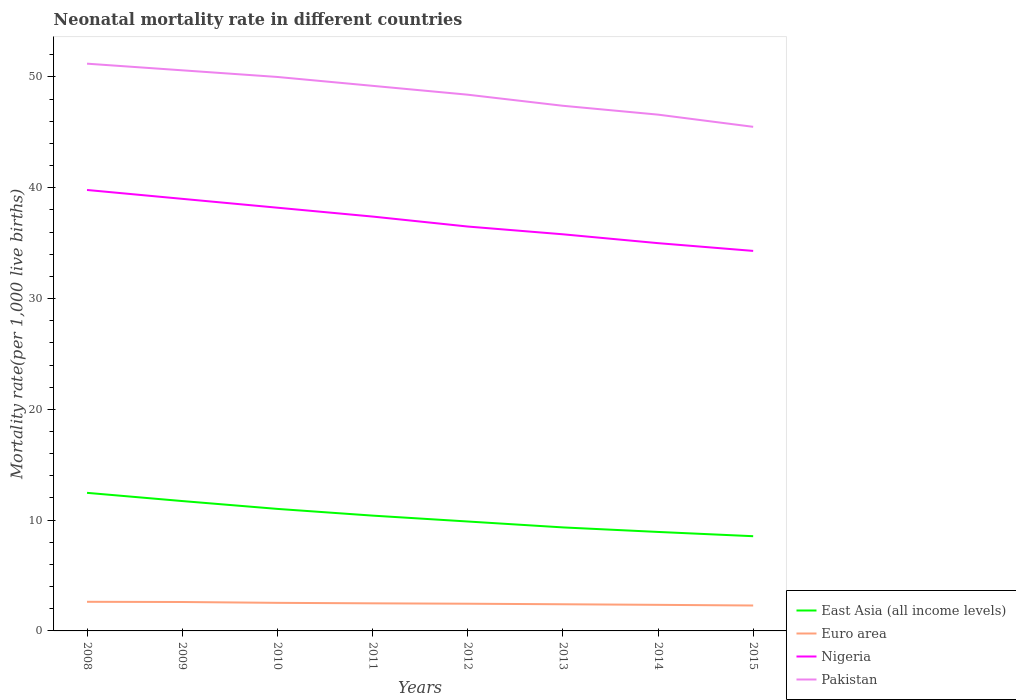How many different coloured lines are there?
Offer a very short reply. 4. Across all years, what is the maximum neonatal mortality rate in Euro area?
Your answer should be compact. 2.29. In which year was the neonatal mortality rate in Pakistan maximum?
Make the answer very short. 2015. What is the total neonatal mortality rate in Pakistan in the graph?
Give a very brief answer. 0.8. What is the difference between the highest and the second highest neonatal mortality rate in Pakistan?
Offer a very short reply. 5.7. How many lines are there?
Your answer should be compact. 4. How many years are there in the graph?
Offer a very short reply. 8. What is the difference between two consecutive major ticks on the Y-axis?
Provide a succinct answer. 10. Does the graph contain any zero values?
Provide a short and direct response. No. Where does the legend appear in the graph?
Make the answer very short. Bottom right. What is the title of the graph?
Offer a terse response. Neonatal mortality rate in different countries. Does "Turks and Caicos Islands" appear as one of the legend labels in the graph?
Your answer should be compact. No. What is the label or title of the Y-axis?
Your response must be concise. Mortality rate(per 1,0 live births). What is the Mortality rate(per 1,000 live births) of East Asia (all income levels) in 2008?
Give a very brief answer. 12.46. What is the Mortality rate(per 1,000 live births) in Euro area in 2008?
Offer a very short reply. 2.63. What is the Mortality rate(per 1,000 live births) of Nigeria in 2008?
Give a very brief answer. 39.8. What is the Mortality rate(per 1,000 live births) of Pakistan in 2008?
Ensure brevity in your answer.  51.2. What is the Mortality rate(per 1,000 live births) of East Asia (all income levels) in 2009?
Give a very brief answer. 11.72. What is the Mortality rate(per 1,000 live births) of Euro area in 2009?
Give a very brief answer. 2.61. What is the Mortality rate(per 1,000 live births) in Pakistan in 2009?
Give a very brief answer. 50.6. What is the Mortality rate(per 1,000 live births) in East Asia (all income levels) in 2010?
Your answer should be compact. 11.01. What is the Mortality rate(per 1,000 live births) of Euro area in 2010?
Offer a terse response. 2.53. What is the Mortality rate(per 1,000 live births) of Nigeria in 2010?
Ensure brevity in your answer.  38.2. What is the Mortality rate(per 1,000 live births) of East Asia (all income levels) in 2011?
Your response must be concise. 10.41. What is the Mortality rate(per 1,000 live births) of Euro area in 2011?
Offer a very short reply. 2.49. What is the Mortality rate(per 1,000 live births) in Nigeria in 2011?
Give a very brief answer. 37.4. What is the Mortality rate(per 1,000 live births) of Pakistan in 2011?
Your answer should be compact. 49.2. What is the Mortality rate(per 1,000 live births) of East Asia (all income levels) in 2012?
Your answer should be compact. 9.88. What is the Mortality rate(per 1,000 live births) of Euro area in 2012?
Your answer should be very brief. 2.46. What is the Mortality rate(per 1,000 live births) in Nigeria in 2012?
Give a very brief answer. 36.5. What is the Mortality rate(per 1,000 live births) in Pakistan in 2012?
Your answer should be compact. 48.4. What is the Mortality rate(per 1,000 live births) of East Asia (all income levels) in 2013?
Your answer should be very brief. 9.34. What is the Mortality rate(per 1,000 live births) in Euro area in 2013?
Keep it short and to the point. 2.41. What is the Mortality rate(per 1,000 live births) in Nigeria in 2013?
Offer a very short reply. 35.8. What is the Mortality rate(per 1,000 live births) of Pakistan in 2013?
Provide a short and direct response. 47.4. What is the Mortality rate(per 1,000 live births) of East Asia (all income levels) in 2014?
Keep it short and to the point. 8.93. What is the Mortality rate(per 1,000 live births) in Euro area in 2014?
Provide a short and direct response. 2.35. What is the Mortality rate(per 1,000 live births) in Pakistan in 2014?
Provide a short and direct response. 46.6. What is the Mortality rate(per 1,000 live births) of East Asia (all income levels) in 2015?
Keep it short and to the point. 8.55. What is the Mortality rate(per 1,000 live births) in Euro area in 2015?
Offer a very short reply. 2.29. What is the Mortality rate(per 1,000 live births) of Nigeria in 2015?
Your answer should be very brief. 34.3. What is the Mortality rate(per 1,000 live births) of Pakistan in 2015?
Your answer should be compact. 45.5. Across all years, what is the maximum Mortality rate(per 1,000 live births) of East Asia (all income levels)?
Offer a very short reply. 12.46. Across all years, what is the maximum Mortality rate(per 1,000 live births) of Euro area?
Your response must be concise. 2.63. Across all years, what is the maximum Mortality rate(per 1,000 live births) in Nigeria?
Your response must be concise. 39.8. Across all years, what is the maximum Mortality rate(per 1,000 live births) in Pakistan?
Your answer should be compact. 51.2. Across all years, what is the minimum Mortality rate(per 1,000 live births) in East Asia (all income levels)?
Give a very brief answer. 8.55. Across all years, what is the minimum Mortality rate(per 1,000 live births) in Euro area?
Give a very brief answer. 2.29. Across all years, what is the minimum Mortality rate(per 1,000 live births) in Nigeria?
Provide a short and direct response. 34.3. Across all years, what is the minimum Mortality rate(per 1,000 live births) of Pakistan?
Make the answer very short. 45.5. What is the total Mortality rate(per 1,000 live births) of East Asia (all income levels) in the graph?
Your answer should be very brief. 82.31. What is the total Mortality rate(per 1,000 live births) in Euro area in the graph?
Ensure brevity in your answer.  19.77. What is the total Mortality rate(per 1,000 live births) of Nigeria in the graph?
Provide a succinct answer. 296. What is the total Mortality rate(per 1,000 live births) of Pakistan in the graph?
Your answer should be compact. 388.9. What is the difference between the Mortality rate(per 1,000 live births) of East Asia (all income levels) in 2008 and that in 2009?
Your response must be concise. 0.74. What is the difference between the Mortality rate(per 1,000 live births) in Euro area in 2008 and that in 2009?
Your answer should be compact. 0.02. What is the difference between the Mortality rate(per 1,000 live births) of Nigeria in 2008 and that in 2009?
Your response must be concise. 0.8. What is the difference between the Mortality rate(per 1,000 live births) of Pakistan in 2008 and that in 2009?
Offer a very short reply. 0.6. What is the difference between the Mortality rate(per 1,000 live births) in East Asia (all income levels) in 2008 and that in 2010?
Give a very brief answer. 1.45. What is the difference between the Mortality rate(per 1,000 live births) in Euro area in 2008 and that in 2010?
Make the answer very short. 0.09. What is the difference between the Mortality rate(per 1,000 live births) of Nigeria in 2008 and that in 2010?
Offer a very short reply. 1.6. What is the difference between the Mortality rate(per 1,000 live births) in East Asia (all income levels) in 2008 and that in 2011?
Provide a short and direct response. 2.06. What is the difference between the Mortality rate(per 1,000 live births) in Euro area in 2008 and that in 2011?
Keep it short and to the point. 0.14. What is the difference between the Mortality rate(per 1,000 live births) in Nigeria in 2008 and that in 2011?
Offer a very short reply. 2.4. What is the difference between the Mortality rate(per 1,000 live births) in Pakistan in 2008 and that in 2011?
Your answer should be compact. 2. What is the difference between the Mortality rate(per 1,000 live births) in East Asia (all income levels) in 2008 and that in 2012?
Your answer should be very brief. 2.59. What is the difference between the Mortality rate(per 1,000 live births) in Euro area in 2008 and that in 2012?
Offer a terse response. 0.17. What is the difference between the Mortality rate(per 1,000 live births) in East Asia (all income levels) in 2008 and that in 2013?
Offer a very short reply. 3.12. What is the difference between the Mortality rate(per 1,000 live births) in Euro area in 2008 and that in 2013?
Give a very brief answer. 0.22. What is the difference between the Mortality rate(per 1,000 live births) of Pakistan in 2008 and that in 2013?
Provide a succinct answer. 3.8. What is the difference between the Mortality rate(per 1,000 live births) of East Asia (all income levels) in 2008 and that in 2014?
Provide a succinct answer. 3.53. What is the difference between the Mortality rate(per 1,000 live births) of Euro area in 2008 and that in 2014?
Your answer should be compact. 0.27. What is the difference between the Mortality rate(per 1,000 live births) in Nigeria in 2008 and that in 2014?
Your response must be concise. 4.8. What is the difference between the Mortality rate(per 1,000 live births) of East Asia (all income levels) in 2008 and that in 2015?
Your response must be concise. 3.91. What is the difference between the Mortality rate(per 1,000 live births) of Euro area in 2008 and that in 2015?
Your answer should be very brief. 0.33. What is the difference between the Mortality rate(per 1,000 live births) in East Asia (all income levels) in 2009 and that in 2010?
Your response must be concise. 0.71. What is the difference between the Mortality rate(per 1,000 live births) in Euro area in 2009 and that in 2010?
Ensure brevity in your answer.  0.08. What is the difference between the Mortality rate(per 1,000 live births) of Nigeria in 2009 and that in 2010?
Keep it short and to the point. 0.8. What is the difference between the Mortality rate(per 1,000 live births) in East Asia (all income levels) in 2009 and that in 2011?
Provide a succinct answer. 1.31. What is the difference between the Mortality rate(per 1,000 live births) in Euro area in 2009 and that in 2011?
Your answer should be compact. 0.12. What is the difference between the Mortality rate(per 1,000 live births) in Nigeria in 2009 and that in 2011?
Provide a succinct answer. 1.6. What is the difference between the Mortality rate(per 1,000 live births) in Pakistan in 2009 and that in 2011?
Your answer should be compact. 1.4. What is the difference between the Mortality rate(per 1,000 live births) in East Asia (all income levels) in 2009 and that in 2012?
Your answer should be compact. 1.84. What is the difference between the Mortality rate(per 1,000 live births) in Euro area in 2009 and that in 2012?
Your answer should be very brief. 0.15. What is the difference between the Mortality rate(per 1,000 live births) of East Asia (all income levels) in 2009 and that in 2013?
Ensure brevity in your answer.  2.38. What is the difference between the Mortality rate(per 1,000 live births) of Euro area in 2009 and that in 2013?
Give a very brief answer. 0.21. What is the difference between the Mortality rate(per 1,000 live births) of Pakistan in 2009 and that in 2013?
Your answer should be compact. 3.2. What is the difference between the Mortality rate(per 1,000 live births) of East Asia (all income levels) in 2009 and that in 2014?
Your answer should be very brief. 2.79. What is the difference between the Mortality rate(per 1,000 live births) in Euro area in 2009 and that in 2014?
Offer a terse response. 0.26. What is the difference between the Mortality rate(per 1,000 live births) of East Asia (all income levels) in 2009 and that in 2015?
Provide a short and direct response. 3.17. What is the difference between the Mortality rate(per 1,000 live births) of Euro area in 2009 and that in 2015?
Provide a succinct answer. 0.32. What is the difference between the Mortality rate(per 1,000 live births) in Pakistan in 2009 and that in 2015?
Your answer should be compact. 5.1. What is the difference between the Mortality rate(per 1,000 live births) of East Asia (all income levels) in 2010 and that in 2011?
Offer a terse response. 0.61. What is the difference between the Mortality rate(per 1,000 live births) of Euro area in 2010 and that in 2011?
Give a very brief answer. 0.04. What is the difference between the Mortality rate(per 1,000 live births) in Nigeria in 2010 and that in 2011?
Keep it short and to the point. 0.8. What is the difference between the Mortality rate(per 1,000 live births) in Pakistan in 2010 and that in 2011?
Keep it short and to the point. 0.8. What is the difference between the Mortality rate(per 1,000 live births) of East Asia (all income levels) in 2010 and that in 2012?
Provide a succinct answer. 1.14. What is the difference between the Mortality rate(per 1,000 live births) in Euro area in 2010 and that in 2012?
Keep it short and to the point. 0.08. What is the difference between the Mortality rate(per 1,000 live births) in Nigeria in 2010 and that in 2012?
Ensure brevity in your answer.  1.7. What is the difference between the Mortality rate(per 1,000 live births) in Pakistan in 2010 and that in 2012?
Offer a very short reply. 1.6. What is the difference between the Mortality rate(per 1,000 live births) of East Asia (all income levels) in 2010 and that in 2013?
Your answer should be very brief. 1.67. What is the difference between the Mortality rate(per 1,000 live births) of Euro area in 2010 and that in 2013?
Ensure brevity in your answer.  0.13. What is the difference between the Mortality rate(per 1,000 live births) of Nigeria in 2010 and that in 2013?
Offer a very short reply. 2.4. What is the difference between the Mortality rate(per 1,000 live births) of East Asia (all income levels) in 2010 and that in 2014?
Provide a succinct answer. 2.08. What is the difference between the Mortality rate(per 1,000 live births) in Euro area in 2010 and that in 2014?
Provide a short and direct response. 0.18. What is the difference between the Mortality rate(per 1,000 live births) in Nigeria in 2010 and that in 2014?
Your answer should be very brief. 3.2. What is the difference between the Mortality rate(per 1,000 live births) of East Asia (all income levels) in 2010 and that in 2015?
Your response must be concise. 2.46. What is the difference between the Mortality rate(per 1,000 live births) in Euro area in 2010 and that in 2015?
Your answer should be very brief. 0.24. What is the difference between the Mortality rate(per 1,000 live births) in Nigeria in 2010 and that in 2015?
Offer a very short reply. 3.9. What is the difference between the Mortality rate(per 1,000 live births) of Pakistan in 2010 and that in 2015?
Your answer should be compact. 4.5. What is the difference between the Mortality rate(per 1,000 live births) of East Asia (all income levels) in 2011 and that in 2012?
Ensure brevity in your answer.  0.53. What is the difference between the Mortality rate(per 1,000 live births) in Euro area in 2011 and that in 2012?
Provide a short and direct response. 0.04. What is the difference between the Mortality rate(per 1,000 live births) of East Asia (all income levels) in 2011 and that in 2013?
Offer a terse response. 1.06. What is the difference between the Mortality rate(per 1,000 live births) of Euro area in 2011 and that in 2013?
Provide a succinct answer. 0.09. What is the difference between the Mortality rate(per 1,000 live births) of Nigeria in 2011 and that in 2013?
Keep it short and to the point. 1.6. What is the difference between the Mortality rate(per 1,000 live births) of East Asia (all income levels) in 2011 and that in 2014?
Your answer should be very brief. 1.47. What is the difference between the Mortality rate(per 1,000 live births) in Euro area in 2011 and that in 2014?
Your answer should be compact. 0.14. What is the difference between the Mortality rate(per 1,000 live births) of Pakistan in 2011 and that in 2014?
Offer a very short reply. 2.6. What is the difference between the Mortality rate(per 1,000 live births) in East Asia (all income levels) in 2011 and that in 2015?
Your answer should be compact. 1.86. What is the difference between the Mortality rate(per 1,000 live births) in Euro area in 2011 and that in 2015?
Provide a succinct answer. 0.2. What is the difference between the Mortality rate(per 1,000 live births) of Pakistan in 2011 and that in 2015?
Make the answer very short. 3.7. What is the difference between the Mortality rate(per 1,000 live births) in East Asia (all income levels) in 2012 and that in 2013?
Provide a short and direct response. 0.53. What is the difference between the Mortality rate(per 1,000 live births) of Euro area in 2012 and that in 2013?
Your answer should be compact. 0.05. What is the difference between the Mortality rate(per 1,000 live births) of Nigeria in 2012 and that in 2013?
Your answer should be very brief. 0.7. What is the difference between the Mortality rate(per 1,000 live births) of Pakistan in 2012 and that in 2013?
Provide a short and direct response. 1. What is the difference between the Mortality rate(per 1,000 live births) of East Asia (all income levels) in 2012 and that in 2014?
Your answer should be compact. 0.94. What is the difference between the Mortality rate(per 1,000 live births) in Euro area in 2012 and that in 2014?
Your answer should be very brief. 0.1. What is the difference between the Mortality rate(per 1,000 live births) in East Asia (all income levels) in 2012 and that in 2015?
Your answer should be very brief. 1.33. What is the difference between the Mortality rate(per 1,000 live births) of Euro area in 2012 and that in 2015?
Offer a very short reply. 0.16. What is the difference between the Mortality rate(per 1,000 live births) of Pakistan in 2012 and that in 2015?
Offer a terse response. 2.9. What is the difference between the Mortality rate(per 1,000 live births) in East Asia (all income levels) in 2013 and that in 2014?
Offer a terse response. 0.41. What is the difference between the Mortality rate(per 1,000 live births) of Euro area in 2013 and that in 2014?
Offer a terse response. 0.05. What is the difference between the Mortality rate(per 1,000 live births) of Nigeria in 2013 and that in 2014?
Ensure brevity in your answer.  0.8. What is the difference between the Mortality rate(per 1,000 live births) of Pakistan in 2013 and that in 2014?
Your response must be concise. 0.8. What is the difference between the Mortality rate(per 1,000 live births) in East Asia (all income levels) in 2013 and that in 2015?
Your answer should be very brief. 0.79. What is the difference between the Mortality rate(per 1,000 live births) of Euro area in 2013 and that in 2015?
Provide a short and direct response. 0.11. What is the difference between the Mortality rate(per 1,000 live births) in Nigeria in 2013 and that in 2015?
Provide a short and direct response. 1.5. What is the difference between the Mortality rate(per 1,000 live births) of East Asia (all income levels) in 2014 and that in 2015?
Offer a very short reply. 0.39. What is the difference between the Mortality rate(per 1,000 live births) in Euro area in 2014 and that in 2015?
Give a very brief answer. 0.06. What is the difference between the Mortality rate(per 1,000 live births) of Pakistan in 2014 and that in 2015?
Make the answer very short. 1.1. What is the difference between the Mortality rate(per 1,000 live births) of East Asia (all income levels) in 2008 and the Mortality rate(per 1,000 live births) of Euro area in 2009?
Your answer should be very brief. 9.85. What is the difference between the Mortality rate(per 1,000 live births) of East Asia (all income levels) in 2008 and the Mortality rate(per 1,000 live births) of Nigeria in 2009?
Provide a short and direct response. -26.54. What is the difference between the Mortality rate(per 1,000 live births) in East Asia (all income levels) in 2008 and the Mortality rate(per 1,000 live births) in Pakistan in 2009?
Ensure brevity in your answer.  -38.14. What is the difference between the Mortality rate(per 1,000 live births) in Euro area in 2008 and the Mortality rate(per 1,000 live births) in Nigeria in 2009?
Your answer should be compact. -36.37. What is the difference between the Mortality rate(per 1,000 live births) in Euro area in 2008 and the Mortality rate(per 1,000 live births) in Pakistan in 2009?
Offer a terse response. -47.97. What is the difference between the Mortality rate(per 1,000 live births) of East Asia (all income levels) in 2008 and the Mortality rate(per 1,000 live births) of Euro area in 2010?
Ensure brevity in your answer.  9.93. What is the difference between the Mortality rate(per 1,000 live births) of East Asia (all income levels) in 2008 and the Mortality rate(per 1,000 live births) of Nigeria in 2010?
Offer a very short reply. -25.74. What is the difference between the Mortality rate(per 1,000 live births) in East Asia (all income levels) in 2008 and the Mortality rate(per 1,000 live births) in Pakistan in 2010?
Provide a short and direct response. -37.54. What is the difference between the Mortality rate(per 1,000 live births) of Euro area in 2008 and the Mortality rate(per 1,000 live births) of Nigeria in 2010?
Provide a short and direct response. -35.57. What is the difference between the Mortality rate(per 1,000 live births) of Euro area in 2008 and the Mortality rate(per 1,000 live births) of Pakistan in 2010?
Offer a very short reply. -47.37. What is the difference between the Mortality rate(per 1,000 live births) of East Asia (all income levels) in 2008 and the Mortality rate(per 1,000 live births) of Euro area in 2011?
Provide a succinct answer. 9.97. What is the difference between the Mortality rate(per 1,000 live births) in East Asia (all income levels) in 2008 and the Mortality rate(per 1,000 live births) in Nigeria in 2011?
Your response must be concise. -24.94. What is the difference between the Mortality rate(per 1,000 live births) of East Asia (all income levels) in 2008 and the Mortality rate(per 1,000 live births) of Pakistan in 2011?
Keep it short and to the point. -36.74. What is the difference between the Mortality rate(per 1,000 live births) in Euro area in 2008 and the Mortality rate(per 1,000 live births) in Nigeria in 2011?
Ensure brevity in your answer.  -34.77. What is the difference between the Mortality rate(per 1,000 live births) in Euro area in 2008 and the Mortality rate(per 1,000 live births) in Pakistan in 2011?
Make the answer very short. -46.57. What is the difference between the Mortality rate(per 1,000 live births) in East Asia (all income levels) in 2008 and the Mortality rate(per 1,000 live births) in Euro area in 2012?
Make the answer very short. 10.01. What is the difference between the Mortality rate(per 1,000 live births) of East Asia (all income levels) in 2008 and the Mortality rate(per 1,000 live births) of Nigeria in 2012?
Your answer should be compact. -24.04. What is the difference between the Mortality rate(per 1,000 live births) in East Asia (all income levels) in 2008 and the Mortality rate(per 1,000 live births) in Pakistan in 2012?
Offer a very short reply. -35.94. What is the difference between the Mortality rate(per 1,000 live births) of Euro area in 2008 and the Mortality rate(per 1,000 live births) of Nigeria in 2012?
Ensure brevity in your answer.  -33.87. What is the difference between the Mortality rate(per 1,000 live births) in Euro area in 2008 and the Mortality rate(per 1,000 live births) in Pakistan in 2012?
Your answer should be compact. -45.77. What is the difference between the Mortality rate(per 1,000 live births) in Nigeria in 2008 and the Mortality rate(per 1,000 live births) in Pakistan in 2012?
Your answer should be compact. -8.6. What is the difference between the Mortality rate(per 1,000 live births) of East Asia (all income levels) in 2008 and the Mortality rate(per 1,000 live births) of Euro area in 2013?
Keep it short and to the point. 10.06. What is the difference between the Mortality rate(per 1,000 live births) in East Asia (all income levels) in 2008 and the Mortality rate(per 1,000 live births) in Nigeria in 2013?
Offer a terse response. -23.34. What is the difference between the Mortality rate(per 1,000 live births) of East Asia (all income levels) in 2008 and the Mortality rate(per 1,000 live births) of Pakistan in 2013?
Ensure brevity in your answer.  -34.94. What is the difference between the Mortality rate(per 1,000 live births) in Euro area in 2008 and the Mortality rate(per 1,000 live births) in Nigeria in 2013?
Give a very brief answer. -33.17. What is the difference between the Mortality rate(per 1,000 live births) of Euro area in 2008 and the Mortality rate(per 1,000 live births) of Pakistan in 2013?
Offer a very short reply. -44.77. What is the difference between the Mortality rate(per 1,000 live births) in East Asia (all income levels) in 2008 and the Mortality rate(per 1,000 live births) in Euro area in 2014?
Your response must be concise. 10.11. What is the difference between the Mortality rate(per 1,000 live births) of East Asia (all income levels) in 2008 and the Mortality rate(per 1,000 live births) of Nigeria in 2014?
Make the answer very short. -22.54. What is the difference between the Mortality rate(per 1,000 live births) of East Asia (all income levels) in 2008 and the Mortality rate(per 1,000 live births) of Pakistan in 2014?
Make the answer very short. -34.14. What is the difference between the Mortality rate(per 1,000 live births) in Euro area in 2008 and the Mortality rate(per 1,000 live births) in Nigeria in 2014?
Offer a very short reply. -32.37. What is the difference between the Mortality rate(per 1,000 live births) of Euro area in 2008 and the Mortality rate(per 1,000 live births) of Pakistan in 2014?
Provide a succinct answer. -43.97. What is the difference between the Mortality rate(per 1,000 live births) of Nigeria in 2008 and the Mortality rate(per 1,000 live births) of Pakistan in 2014?
Offer a terse response. -6.8. What is the difference between the Mortality rate(per 1,000 live births) of East Asia (all income levels) in 2008 and the Mortality rate(per 1,000 live births) of Euro area in 2015?
Ensure brevity in your answer.  10.17. What is the difference between the Mortality rate(per 1,000 live births) in East Asia (all income levels) in 2008 and the Mortality rate(per 1,000 live births) in Nigeria in 2015?
Offer a very short reply. -21.84. What is the difference between the Mortality rate(per 1,000 live births) in East Asia (all income levels) in 2008 and the Mortality rate(per 1,000 live births) in Pakistan in 2015?
Offer a terse response. -33.04. What is the difference between the Mortality rate(per 1,000 live births) in Euro area in 2008 and the Mortality rate(per 1,000 live births) in Nigeria in 2015?
Your answer should be compact. -31.67. What is the difference between the Mortality rate(per 1,000 live births) in Euro area in 2008 and the Mortality rate(per 1,000 live births) in Pakistan in 2015?
Your answer should be compact. -42.87. What is the difference between the Mortality rate(per 1,000 live births) in Nigeria in 2008 and the Mortality rate(per 1,000 live births) in Pakistan in 2015?
Your answer should be very brief. -5.7. What is the difference between the Mortality rate(per 1,000 live births) in East Asia (all income levels) in 2009 and the Mortality rate(per 1,000 live births) in Euro area in 2010?
Offer a terse response. 9.19. What is the difference between the Mortality rate(per 1,000 live births) of East Asia (all income levels) in 2009 and the Mortality rate(per 1,000 live births) of Nigeria in 2010?
Make the answer very short. -26.48. What is the difference between the Mortality rate(per 1,000 live births) in East Asia (all income levels) in 2009 and the Mortality rate(per 1,000 live births) in Pakistan in 2010?
Your response must be concise. -38.28. What is the difference between the Mortality rate(per 1,000 live births) in Euro area in 2009 and the Mortality rate(per 1,000 live births) in Nigeria in 2010?
Ensure brevity in your answer.  -35.59. What is the difference between the Mortality rate(per 1,000 live births) of Euro area in 2009 and the Mortality rate(per 1,000 live births) of Pakistan in 2010?
Your response must be concise. -47.39. What is the difference between the Mortality rate(per 1,000 live births) in East Asia (all income levels) in 2009 and the Mortality rate(per 1,000 live births) in Euro area in 2011?
Provide a short and direct response. 9.23. What is the difference between the Mortality rate(per 1,000 live births) in East Asia (all income levels) in 2009 and the Mortality rate(per 1,000 live births) in Nigeria in 2011?
Offer a very short reply. -25.68. What is the difference between the Mortality rate(per 1,000 live births) of East Asia (all income levels) in 2009 and the Mortality rate(per 1,000 live births) of Pakistan in 2011?
Provide a short and direct response. -37.48. What is the difference between the Mortality rate(per 1,000 live births) of Euro area in 2009 and the Mortality rate(per 1,000 live births) of Nigeria in 2011?
Offer a very short reply. -34.79. What is the difference between the Mortality rate(per 1,000 live births) of Euro area in 2009 and the Mortality rate(per 1,000 live births) of Pakistan in 2011?
Provide a succinct answer. -46.59. What is the difference between the Mortality rate(per 1,000 live births) in East Asia (all income levels) in 2009 and the Mortality rate(per 1,000 live births) in Euro area in 2012?
Provide a succinct answer. 9.27. What is the difference between the Mortality rate(per 1,000 live births) of East Asia (all income levels) in 2009 and the Mortality rate(per 1,000 live births) of Nigeria in 2012?
Ensure brevity in your answer.  -24.78. What is the difference between the Mortality rate(per 1,000 live births) in East Asia (all income levels) in 2009 and the Mortality rate(per 1,000 live births) in Pakistan in 2012?
Offer a very short reply. -36.68. What is the difference between the Mortality rate(per 1,000 live births) in Euro area in 2009 and the Mortality rate(per 1,000 live births) in Nigeria in 2012?
Ensure brevity in your answer.  -33.89. What is the difference between the Mortality rate(per 1,000 live births) of Euro area in 2009 and the Mortality rate(per 1,000 live births) of Pakistan in 2012?
Provide a succinct answer. -45.79. What is the difference between the Mortality rate(per 1,000 live births) of Nigeria in 2009 and the Mortality rate(per 1,000 live births) of Pakistan in 2012?
Your answer should be very brief. -9.4. What is the difference between the Mortality rate(per 1,000 live births) in East Asia (all income levels) in 2009 and the Mortality rate(per 1,000 live births) in Euro area in 2013?
Offer a terse response. 9.32. What is the difference between the Mortality rate(per 1,000 live births) in East Asia (all income levels) in 2009 and the Mortality rate(per 1,000 live births) in Nigeria in 2013?
Your answer should be very brief. -24.08. What is the difference between the Mortality rate(per 1,000 live births) in East Asia (all income levels) in 2009 and the Mortality rate(per 1,000 live births) in Pakistan in 2013?
Your response must be concise. -35.68. What is the difference between the Mortality rate(per 1,000 live births) in Euro area in 2009 and the Mortality rate(per 1,000 live births) in Nigeria in 2013?
Provide a short and direct response. -33.19. What is the difference between the Mortality rate(per 1,000 live births) of Euro area in 2009 and the Mortality rate(per 1,000 live births) of Pakistan in 2013?
Your response must be concise. -44.79. What is the difference between the Mortality rate(per 1,000 live births) of Nigeria in 2009 and the Mortality rate(per 1,000 live births) of Pakistan in 2013?
Offer a very short reply. -8.4. What is the difference between the Mortality rate(per 1,000 live births) of East Asia (all income levels) in 2009 and the Mortality rate(per 1,000 live births) of Euro area in 2014?
Your answer should be compact. 9.37. What is the difference between the Mortality rate(per 1,000 live births) in East Asia (all income levels) in 2009 and the Mortality rate(per 1,000 live births) in Nigeria in 2014?
Give a very brief answer. -23.28. What is the difference between the Mortality rate(per 1,000 live births) in East Asia (all income levels) in 2009 and the Mortality rate(per 1,000 live births) in Pakistan in 2014?
Provide a short and direct response. -34.88. What is the difference between the Mortality rate(per 1,000 live births) of Euro area in 2009 and the Mortality rate(per 1,000 live births) of Nigeria in 2014?
Provide a short and direct response. -32.39. What is the difference between the Mortality rate(per 1,000 live births) of Euro area in 2009 and the Mortality rate(per 1,000 live births) of Pakistan in 2014?
Make the answer very short. -43.99. What is the difference between the Mortality rate(per 1,000 live births) in Nigeria in 2009 and the Mortality rate(per 1,000 live births) in Pakistan in 2014?
Give a very brief answer. -7.6. What is the difference between the Mortality rate(per 1,000 live births) in East Asia (all income levels) in 2009 and the Mortality rate(per 1,000 live births) in Euro area in 2015?
Your answer should be compact. 9.43. What is the difference between the Mortality rate(per 1,000 live births) of East Asia (all income levels) in 2009 and the Mortality rate(per 1,000 live births) of Nigeria in 2015?
Your answer should be compact. -22.58. What is the difference between the Mortality rate(per 1,000 live births) of East Asia (all income levels) in 2009 and the Mortality rate(per 1,000 live births) of Pakistan in 2015?
Your response must be concise. -33.78. What is the difference between the Mortality rate(per 1,000 live births) of Euro area in 2009 and the Mortality rate(per 1,000 live births) of Nigeria in 2015?
Your response must be concise. -31.69. What is the difference between the Mortality rate(per 1,000 live births) of Euro area in 2009 and the Mortality rate(per 1,000 live births) of Pakistan in 2015?
Provide a succinct answer. -42.89. What is the difference between the Mortality rate(per 1,000 live births) in Nigeria in 2009 and the Mortality rate(per 1,000 live births) in Pakistan in 2015?
Provide a succinct answer. -6.5. What is the difference between the Mortality rate(per 1,000 live births) of East Asia (all income levels) in 2010 and the Mortality rate(per 1,000 live births) of Euro area in 2011?
Provide a short and direct response. 8.52. What is the difference between the Mortality rate(per 1,000 live births) in East Asia (all income levels) in 2010 and the Mortality rate(per 1,000 live births) in Nigeria in 2011?
Make the answer very short. -26.39. What is the difference between the Mortality rate(per 1,000 live births) of East Asia (all income levels) in 2010 and the Mortality rate(per 1,000 live births) of Pakistan in 2011?
Offer a terse response. -38.19. What is the difference between the Mortality rate(per 1,000 live births) in Euro area in 2010 and the Mortality rate(per 1,000 live births) in Nigeria in 2011?
Provide a short and direct response. -34.87. What is the difference between the Mortality rate(per 1,000 live births) of Euro area in 2010 and the Mortality rate(per 1,000 live births) of Pakistan in 2011?
Give a very brief answer. -46.67. What is the difference between the Mortality rate(per 1,000 live births) of East Asia (all income levels) in 2010 and the Mortality rate(per 1,000 live births) of Euro area in 2012?
Your response must be concise. 8.56. What is the difference between the Mortality rate(per 1,000 live births) of East Asia (all income levels) in 2010 and the Mortality rate(per 1,000 live births) of Nigeria in 2012?
Your answer should be very brief. -25.49. What is the difference between the Mortality rate(per 1,000 live births) in East Asia (all income levels) in 2010 and the Mortality rate(per 1,000 live births) in Pakistan in 2012?
Ensure brevity in your answer.  -37.39. What is the difference between the Mortality rate(per 1,000 live births) of Euro area in 2010 and the Mortality rate(per 1,000 live births) of Nigeria in 2012?
Ensure brevity in your answer.  -33.97. What is the difference between the Mortality rate(per 1,000 live births) of Euro area in 2010 and the Mortality rate(per 1,000 live births) of Pakistan in 2012?
Your response must be concise. -45.87. What is the difference between the Mortality rate(per 1,000 live births) in Nigeria in 2010 and the Mortality rate(per 1,000 live births) in Pakistan in 2012?
Give a very brief answer. -10.2. What is the difference between the Mortality rate(per 1,000 live births) in East Asia (all income levels) in 2010 and the Mortality rate(per 1,000 live births) in Euro area in 2013?
Ensure brevity in your answer.  8.61. What is the difference between the Mortality rate(per 1,000 live births) in East Asia (all income levels) in 2010 and the Mortality rate(per 1,000 live births) in Nigeria in 2013?
Offer a very short reply. -24.79. What is the difference between the Mortality rate(per 1,000 live births) in East Asia (all income levels) in 2010 and the Mortality rate(per 1,000 live births) in Pakistan in 2013?
Offer a terse response. -36.39. What is the difference between the Mortality rate(per 1,000 live births) of Euro area in 2010 and the Mortality rate(per 1,000 live births) of Nigeria in 2013?
Your response must be concise. -33.27. What is the difference between the Mortality rate(per 1,000 live births) of Euro area in 2010 and the Mortality rate(per 1,000 live births) of Pakistan in 2013?
Provide a succinct answer. -44.87. What is the difference between the Mortality rate(per 1,000 live births) in East Asia (all income levels) in 2010 and the Mortality rate(per 1,000 live births) in Euro area in 2014?
Give a very brief answer. 8.66. What is the difference between the Mortality rate(per 1,000 live births) in East Asia (all income levels) in 2010 and the Mortality rate(per 1,000 live births) in Nigeria in 2014?
Give a very brief answer. -23.99. What is the difference between the Mortality rate(per 1,000 live births) of East Asia (all income levels) in 2010 and the Mortality rate(per 1,000 live births) of Pakistan in 2014?
Make the answer very short. -35.59. What is the difference between the Mortality rate(per 1,000 live births) of Euro area in 2010 and the Mortality rate(per 1,000 live births) of Nigeria in 2014?
Provide a succinct answer. -32.47. What is the difference between the Mortality rate(per 1,000 live births) in Euro area in 2010 and the Mortality rate(per 1,000 live births) in Pakistan in 2014?
Your response must be concise. -44.07. What is the difference between the Mortality rate(per 1,000 live births) of East Asia (all income levels) in 2010 and the Mortality rate(per 1,000 live births) of Euro area in 2015?
Offer a terse response. 8.72. What is the difference between the Mortality rate(per 1,000 live births) of East Asia (all income levels) in 2010 and the Mortality rate(per 1,000 live births) of Nigeria in 2015?
Keep it short and to the point. -23.29. What is the difference between the Mortality rate(per 1,000 live births) of East Asia (all income levels) in 2010 and the Mortality rate(per 1,000 live births) of Pakistan in 2015?
Your response must be concise. -34.49. What is the difference between the Mortality rate(per 1,000 live births) in Euro area in 2010 and the Mortality rate(per 1,000 live births) in Nigeria in 2015?
Make the answer very short. -31.77. What is the difference between the Mortality rate(per 1,000 live births) in Euro area in 2010 and the Mortality rate(per 1,000 live births) in Pakistan in 2015?
Provide a succinct answer. -42.97. What is the difference between the Mortality rate(per 1,000 live births) in Nigeria in 2010 and the Mortality rate(per 1,000 live births) in Pakistan in 2015?
Offer a terse response. -7.3. What is the difference between the Mortality rate(per 1,000 live births) in East Asia (all income levels) in 2011 and the Mortality rate(per 1,000 live births) in Euro area in 2012?
Offer a terse response. 7.95. What is the difference between the Mortality rate(per 1,000 live births) of East Asia (all income levels) in 2011 and the Mortality rate(per 1,000 live births) of Nigeria in 2012?
Offer a terse response. -26.09. What is the difference between the Mortality rate(per 1,000 live births) of East Asia (all income levels) in 2011 and the Mortality rate(per 1,000 live births) of Pakistan in 2012?
Your response must be concise. -37.99. What is the difference between the Mortality rate(per 1,000 live births) of Euro area in 2011 and the Mortality rate(per 1,000 live births) of Nigeria in 2012?
Provide a short and direct response. -34.01. What is the difference between the Mortality rate(per 1,000 live births) in Euro area in 2011 and the Mortality rate(per 1,000 live births) in Pakistan in 2012?
Your response must be concise. -45.91. What is the difference between the Mortality rate(per 1,000 live births) of East Asia (all income levels) in 2011 and the Mortality rate(per 1,000 live births) of Euro area in 2013?
Offer a terse response. 8. What is the difference between the Mortality rate(per 1,000 live births) of East Asia (all income levels) in 2011 and the Mortality rate(per 1,000 live births) of Nigeria in 2013?
Offer a terse response. -25.39. What is the difference between the Mortality rate(per 1,000 live births) in East Asia (all income levels) in 2011 and the Mortality rate(per 1,000 live births) in Pakistan in 2013?
Your response must be concise. -36.99. What is the difference between the Mortality rate(per 1,000 live births) of Euro area in 2011 and the Mortality rate(per 1,000 live births) of Nigeria in 2013?
Your answer should be compact. -33.31. What is the difference between the Mortality rate(per 1,000 live births) of Euro area in 2011 and the Mortality rate(per 1,000 live births) of Pakistan in 2013?
Ensure brevity in your answer.  -44.91. What is the difference between the Mortality rate(per 1,000 live births) in Nigeria in 2011 and the Mortality rate(per 1,000 live births) in Pakistan in 2013?
Your response must be concise. -10. What is the difference between the Mortality rate(per 1,000 live births) in East Asia (all income levels) in 2011 and the Mortality rate(per 1,000 live births) in Euro area in 2014?
Your answer should be very brief. 8.05. What is the difference between the Mortality rate(per 1,000 live births) of East Asia (all income levels) in 2011 and the Mortality rate(per 1,000 live births) of Nigeria in 2014?
Your answer should be compact. -24.59. What is the difference between the Mortality rate(per 1,000 live births) of East Asia (all income levels) in 2011 and the Mortality rate(per 1,000 live births) of Pakistan in 2014?
Offer a terse response. -36.19. What is the difference between the Mortality rate(per 1,000 live births) of Euro area in 2011 and the Mortality rate(per 1,000 live births) of Nigeria in 2014?
Offer a very short reply. -32.51. What is the difference between the Mortality rate(per 1,000 live births) in Euro area in 2011 and the Mortality rate(per 1,000 live births) in Pakistan in 2014?
Your response must be concise. -44.11. What is the difference between the Mortality rate(per 1,000 live births) in East Asia (all income levels) in 2011 and the Mortality rate(per 1,000 live births) in Euro area in 2015?
Your answer should be very brief. 8.11. What is the difference between the Mortality rate(per 1,000 live births) in East Asia (all income levels) in 2011 and the Mortality rate(per 1,000 live births) in Nigeria in 2015?
Provide a succinct answer. -23.89. What is the difference between the Mortality rate(per 1,000 live births) in East Asia (all income levels) in 2011 and the Mortality rate(per 1,000 live births) in Pakistan in 2015?
Provide a short and direct response. -35.09. What is the difference between the Mortality rate(per 1,000 live births) of Euro area in 2011 and the Mortality rate(per 1,000 live births) of Nigeria in 2015?
Your answer should be very brief. -31.81. What is the difference between the Mortality rate(per 1,000 live births) in Euro area in 2011 and the Mortality rate(per 1,000 live births) in Pakistan in 2015?
Offer a very short reply. -43.01. What is the difference between the Mortality rate(per 1,000 live births) of Nigeria in 2011 and the Mortality rate(per 1,000 live births) of Pakistan in 2015?
Ensure brevity in your answer.  -8.1. What is the difference between the Mortality rate(per 1,000 live births) of East Asia (all income levels) in 2012 and the Mortality rate(per 1,000 live births) of Euro area in 2013?
Ensure brevity in your answer.  7.47. What is the difference between the Mortality rate(per 1,000 live births) in East Asia (all income levels) in 2012 and the Mortality rate(per 1,000 live births) in Nigeria in 2013?
Provide a succinct answer. -25.92. What is the difference between the Mortality rate(per 1,000 live births) in East Asia (all income levels) in 2012 and the Mortality rate(per 1,000 live births) in Pakistan in 2013?
Make the answer very short. -37.52. What is the difference between the Mortality rate(per 1,000 live births) in Euro area in 2012 and the Mortality rate(per 1,000 live births) in Nigeria in 2013?
Offer a terse response. -33.34. What is the difference between the Mortality rate(per 1,000 live births) in Euro area in 2012 and the Mortality rate(per 1,000 live births) in Pakistan in 2013?
Your response must be concise. -44.94. What is the difference between the Mortality rate(per 1,000 live births) in Nigeria in 2012 and the Mortality rate(per 1,000 live births) in Pakistan in 2013?
Make the answer very short. -10.9. What is the difference between the Mortality rate(per 1,000 live births) of East Asia (all income levels) in 2012 and the Mortality rate(per 1,000 live births) of Euro area in 2014?
Give a very brief answer. 7.52. What is the difference between the Mortality rate(per 1,000 live births) of East Asia (all income levels) in 2012 and the Mortality rate(per 1,000 live births) of Nigeria in 2014?
Give a very brief answer. -25.12. What is the difference between the Mortality rate(per 1,000 live births) in East Asia (all income levels) in 2012 and the Mortality rate(per 1,000 live births) in Pakistan in 2014?
Provide a short and direct response. -36.72. What is the difference between the Mortality rate(per 1,000 live births) in Euro area in 2012 and the Mortality rate(per 1,000 live births) in Nigeria in 2014?
Keep it short and to the point. -32.54. What is the difference between the Mortality rate(per 1,000 live births) of Euro area in 2012 and the Mortality rate(per 1,000 live births) of Pakistan in 2014?
Ensure brevity in your answer.  -44.14. What is the difference between the Mortality rate(per 1,000 live births) in Nigeria in 2012 and the Mortality rate(per 1,000 live births) in Pakistan in 2014?
Your response must be concise. -10.1. What is the difference between the Mortality rate(per 1,000 live births) in East Asia (all income levels) in 2012 and the Mortality rate(per 1,000 live births) in Euro area in 2015?
Provide a succinct answer. 7.58. What is the difference between the Mortality rate(per 1,000 live births) of East Asia (all income levels) in 2012 and the Mortality rate(per 1,000 live births) of Nigeria in 2015?
Keep it short and to the point. -24.42. What is the difference between the Mortality rate(per 1,000 live births) of East Asia (all income levels) in 2012 and the Mortality rate(per 1,000 live births) of Pakistan in 2015?
Your answer should be compact. -35.62. What is the difference between the Mortality rate(per 1,000 live births) of Euro area in 2012 and the Mortality rate(per 1,000 live births) of Nigeria in 2015?
Provide a succinct answer. -31.84. What is the difference between the Mortality rate(per 1,000 live births) of Euro area in 2012 and the Mortality rate(per 1,000 live births) of Pakistan in 2015?
Keep it short and to the point. -43.04. What is the difference between the Mortality rate(per 1,000 live births) of East Asia (all income levels) in 2013 and the Mortality rate(per 1,000 live births) of Euro area in 2014?
Offer a very short reply. 6.99. What is the difference between the Mortality rate(per 1,000 live births) of East Asia (all income levels) in 2013 and the Mortality rate(per 1,000 live births) of Nigeria in 2014?
Provide a short and direct response. -25.66. What is the difference between the Mortality rate(per 1,000 live births) in East Asia (all income levels) in 2013 and the Mortality rate(per 1,000 live births) in Pakistan in 2014?
Provide a short and direct response. -37.26. What is the difference between the Mortality rate(per 1,000 live births) of Euro area in 2013 and the Mortality rate(per 1,000 live births) of Nigeria in 2014?
Provide a succinct answer. -32.59. What is the difference between the Mortality rate(per 1,000 live births) in Euro area in 2013 and the Mortality rate(per 1,000 live births) in Pakistan in 2014?
Your answer should be compact. -44.19. What is the difference between the Mortality rate(per 1,000 live births) in Nigeria in 2013 and the Mortality rate(per 1,000 live births) in Pakistan in 2014?
Provide a succinct answer. -10.8. What is the difference between the Mortality rate(per 1,000 live births) of East Asia (all income levels) in 2013 and the Mortality rate(per 1,000 live births) of Euro area in 2015?
Give a very brief answer. 7.05. What is the difference between the Mortality rate(per 1,000 live births) of East Asia (all income levels) in 2013 and the Mortality rate(per 1,000 live births) of Nigeria in 2015?
Provide a short and direct response. -24.96. What is the difference between the Mortality rate(per 1,000 live births) in East Asia (all income levels) in 2013 and the Mortality rate(per 1,000 live births) in Pakistan in 2015?
Your response must be concise. -36.16. What is the difference between the Mortality rate(per 1,000 live births) of Euro area in 2013 and the Mortality rate(per 1,000 live births) of Nigeria in 2015?
Your answer should be compact. -31.89. What is the difference between the Mortality rate(per 1,000 live births) in Euro area in 2013 and the Mortality rate(per 1,000 live births) in Pakistan in 2015?
Offer a terse response. -43.09. What is the difference between the Mortality rate(per 1,000 live births) of Nigeria in 2013 and the Mortality rate(per 1,000 live births) of Pakistan in 2015?
Make the answer very short. -9.7. What is the difference between the Mortality rate(per 1,000 live births) of East Asia (all income levels) in 2014 and the Mortality rate(per 1,000 live births) of Euro area in 2015?
Ensure brevity in your answer.  6.64. What is the difference between the Mortality rate(per 1,000 live births) of East Asia (all income levels) in 2014 and the Mortality rate(per 1,000 live births) of Nigeria in 2015?
Ensure brevity in your answer.  -25.37. What is the difference between the Mortality rate(per 1,000 live births) of East Asia (all income levels) in 2014 and the Mortality rate(per 1,000 live births) of Pakistan in 2015?
Offer a very short reply. -36.57. What is the difference between the Mortality rate(per 1,000 live births) of Euro area in 2014 and the Mortality rate(per 1,000 live births) of Nigeria in 2015?
Ensure brevity in your answer.  -31.95. What is the difference between the Mortality rate(per 1,000 live births) of Euro area in 2014 and the Mortality rate(per 1,000 live births) of Pakistan in 2015?
Give a very brief answer. -43.15. What is the difference between the Mortality rate(per 1,000 live births) of Nigeria in 2014 and the Mortality rate(per 1,000 live births) of Pakistan in 2015?
Offer a very short reply. -10.5. What is the average Mortality rate(per 1,000 live births) of East Asia (all income levels) per year?
Make the answer very short. 10.29. What is the average Mortality rate(per 1,000 live births) of Euro area per year?
Offer a terse response. 2.47. What is the average Mortality rate(per 1,000 live births) of Pakistan per year?
Offer a terse response. 48.61. In the year 2008, what is the difference between the Mortality rate(per 1,000 live births) of East Asia (all income levels) and Mortality rate(per 1,000 live births) of Euro area?
Make the answer very short. 9.84. In the year 2008, what is the difference between the Mortality rate(per 1,000 live births) of East Asia (all income levels) and Mortality rate(per 1,000 live births) of Nigeria?
Your answer should be compact. -27.34. In the year 2008, what is the difference between the Mortality rate(per 1,000 live births) of East Asia (all income levels) and Mortality rate(per 1,000 live births) of Pakistan?
Your answer should be very brief. -38.74. In the year 2008, what is the difference between the Mortality rate(per 1,000 live births) in Euro area and Mortality rate(per 1,000 live births) in Nigeria?
Your answer should be very brief. -37.17. In the year 2008, what is the difference between the Mortality rate(per 1,000 live births) of Euro area and Mortality rate(per 1,000 live births) of Pakistan?
Your answer should be very brief. -48.57. In the year 2009, what is the difference between the Mortality rate(per 1,000 live births) of East Asia (all income levels) and Mortality rate(per 1,000 live births) of Euro area?
Your answer should be very brief. 9.11. In the year 2009, what is the difference between the Mortality rate(per 1,000 live births) in East Asia (all income levels) and Mortality rate(per 1,000 live births) in Nigeria?
Offer a terse response. -27.28. In the year 2009, what is the difference between the Mortality rate(per 1,000 live births) in East Asia (all income levels) and Mortality rate(per 1,000 live births) in Pakistan?
Offer a very short reply. -38.88. In the year 2009, what is the difference between the Mortality rate(per 1,000 live births) in Euro area and Mortality rate(per 1,000 live births) in Nigeria?
Ensure brevity in your answer.  -36.39. In the year 2009, what is the difference between the Mortality rate(per 1,000 live births) of Euro area and Mortality rate(per 1,000 live births) of Pakistan?
Offer a terse response. -47.99. In the year 2009, what is the difference between the Mortality rate(per 1,000 live births) in Nigeria and Mortality rate(per 1,000 live births) in Pakistan?
Keep it short and to the point. -11.6. In the year 2010, what is the difference between the Mortality rate(per 1,000 live births) in East Asia (all income levels) and Mortality rate(per 1,000 live births) in Euro area?
Keep it short and to the point. 8.48. In the year 2010, what is the difference between the Mortality rate(per 1,000 live births) of East Asia (all income levels) and Mortality rate(per 1,000 live births) of Nigeria?
Make the answer very short. -27.19. In the year 2010, what is the difference between the Mortality rate(per 1,000 live births) in East Asia (all income levels) and Mortality rate(per 1,000 live births) in Pakistan?
Your answer should be very brief. -38.99. In the year 2010, what is the difference between the Mortality rate(per 1,000 live births) in Euro area and Mortality rate(per 1,000 live births) in Nigeria?
Keep it short and to the point. -35.67. In the year 2010, what is the difference between the Mortality rate(per 1,000 live births) in Euro area and Mortality rate(per 1,000 live births) in Pakistan?
Offer a very short reply. -47.47. In the year 2011, what is the difference between the Mortality rate(per 1,000 live births) of East Asia (all income levels) and Mortality rate(per 1,000 live births) of Euro area?
Provide a short and direct response. 7.92. In the year 2011, what is the difference between the Mortality rate(per 1,000 live births) in East Asia (all income levels) and Mortality rate(per 1,000 live births) in Nigeria?
Your answer should be compact. -26.99. In the year 2011, what is the difference between the Mortality rate(per 1,000 live births) of East Asia (all income levels) and Mortality rate(per 1,000 live births) of Pakistan?
Offer a very short reply. -38.79. In the year 2011, what is the difference between the Mortality rate(per 1,000 live births) in Euro area and Mortality rate(per 1,000 live births) in Nigeria?
Provide a succinct answer. -34.91. In the year 2011, what is the difference between the Mortality rate(per 1,000 live births) of Euro area and Mortality rate(per 1,000 live births) of Pakistan?
Provide a succinct answer. -46.71. In the year 2011, what is the difference between the Mortality rate(per 1,000 live births) of Nigeria and Mortality rate(per 1,000 live births) of Pakistan?
Give a very brief answer. -11.8. In the year 2012, what is the difference between the Mortality rate(per 1,000 live births) of East Asia (all income levels) and Mortality rate(per 1,000 live births) of Euro area?
Your answer should be very brief. 7.42. In the year 2012, what is the difference between the Mortality rate(per 1,000 live births) of East Asia (all income levels) and Mortality rate(per 1,000 live births) of Nigeria?
Provide a succinct answer. -26.62. In the year 2012, what is the difference between the Mortality rate(per 1,000 live births) of East Asia (all income levels) and Mortality rate(per 1,000 live births) of Pakistan?
Make the answer very short. -38.52. In the year 2012, what is the difference between the Mortality rate(per 1,000 live births) in Euro area and Mortality rate(per 1,000 live births) in Nigeria?
Offer a terse response. -34.04. In the year 2012, what is the difference between the Mortality rate(per 1,000 live births) in Euro area and Mortality rate(per 1,000 live births) in Pakistan?
Keep it short and to the point. -45.94. In the year 2013, what is the difference between the Mortality rate(per 1,000 live births) of East Asia (all income levels) and Mortality rate(per 1,000 live births) of Euro area?
Your answer should be compact. 6.94. In the year 2013, what is the difference between the Mortality rate(per 1,000 live births) in East Asia (all income levels) and Mortality rate(per 1,000 live births) in Nigeria?
Provide a short and direct response. -26.46. In the year 2013, what is the difference between the Mortality rate(per 1,000 live births) of East Asia (all income levels) and Mortality rate(per 1,000 live births) of Pakistan?
Give a very brief answer. -38.06. In the year 2013, what is the difference between the Mortality rate(per 1,000 live births) in Euro area and Mortality rate(per 1,000 live births) in Nigeria?
Your answer should be very brief. -33.39. In the year 2013, what is the difference between the Mortality rate(per 1,000 live births) in Euro area and Mortality rate(per 1,000 live births) in Pakistan?
Ensure brevity in your answer.  -44.99. In the year 2013, what is the difference between the Mortality rate(per 1,000 live births) in Nigeria and Mortality rate(per 1,000 live births) in Pakistan?
Keep it short and to the point. -11.6. In the year 2014, what is the difference between the Mortality rate(per 1,000 live births) of East Asia (all income levels) and Mortality rate(per 1,000 live births) of Euro area?
Your answer should be compact. 6.58. In the year 2014, what is the difference between the Mortality rate(per 1,000 live births) of East Asia (all income levels) and Mortality rate(per 1,000 live births) of Nigeria?
Provide a short and direct response. -26.07. In the year 2014, what is the difference between the Mortality rate(per 1,000 live births) in East Asia (all income levels) and Mortality rate(per 1,000 live births) in Pakistan?
Offer a very short reply. -37.67. In the year 2014, what is the difference between the Mortality rate(per 1,000 live births) in Euro area and Mortality rate(per 1,000 live births) in Nigeria?
Give a very brief answer. -32.65. In the year 2014, what is the difference between the Mortality rate(per 1,000 live births) of Euro area and Mortality rate(per 1,000 live births) of Pakistan?
Give a very brief answer. -44.25. In the year 2014, what is the difference between the Mortality rate(per 1,000 live births) of Nigeria and Mortality rate(per 1,000 live births) of Pakistan?
Your answer should be compact. -11.6. In the year 2015, what is the difference between the Mortality rate(per 1,000 live births) of East Asia (all income levels) and Mortality rate(per 1,000 live births) of Euro area?
Give a very brief answer. 6.26. In the year 2015, what is the difference between the Mortality rate(per 1,000 live births) of East Asia (all income levels) and Mortality rate(per 1,000 live births) of Nigeria?
Keep it short and to the point. -25.75. In the year 2015, what is the difference between the Mortality rate(per 1,000 live births) in East Asia (all income levels) and Mortality rate(per 1,000 live births) in Pakistan?
Make the answer very short. -36.95. In the year 2015, what is the difference between the Mortality rate(per 1,000 live births) of Euro area and Mortality rate(per 1,000 live births) of Nigeria?
Offer a terse response. -32.01. In the year 2015, what is the difference between the Mortality rate(per 1,000 live births) of Euro area and Mortality rate(per 1,000 live births) of Pakistan?
Provide a succinct answer. -43.21. In the year 2015, what is the difference between the Mortality rate(per 1,000 live births) in Nigeria and Mortality rate(per 1,000 live births) in Pakistan?
Your response must be concise. -11.2. What is the ratio of the Mortality rate(per 1,000 live births) in East Asia (all income levels) in 2008 to that in 2009?
Your answer should be very brief. 1.06. What is the ratio of the Mortality rate(per 1,000 live births) in Euro area in 2008 to that in 2009?
Your answer should be compact. 1.01. What is the ratio of the Mortality rate(per 1,000 live births) in Nigeria in 2008 to that in 2009?
Give a very brief answer. 1.02. What is the ratio of the Mortality rate(per 1,000 live births) of Pakistan in 2008 to that in 2009?
Ensure brevity in your answer.  1.01. What is the ratio of the Mortality rate(per 1,000 live births) of East Asia (all income levels) in 2008 to that in 2010?
Provide a short and direct response. 1.13. What is the ratio of the Mortality rate(per 1,000 live births) of Euro area in 2008 to that in 2010?
Your answer should be compact. 1.04. What is the ratio of the Mortality rate(per 1,000 live births) in Nigeria in 2008 to that in 2010?
Give a very brief answer. 1.04. What is the ratio of the Mortality rate(per 1,000 live births) in Pakistan in 2008 to that in 2010?
Offer a terse response. 1.02. What is the ratio of the Mortality rate(per 1,000 live births) of East Asia (all income levels) in 2008 to that in 2011?
Your answer should be compact. 1.2. What is the ratio of the Mortality rate(per 1,000 live births) in Euro area in 2008 to that in 2011?
Ensure brevity in your answer.  1.06. What is the ratio of the Mortality rate(per 1,000 live births) in Nigeria in 2008 to that in 2011?
Offer a very short reply. 1.06. What is the ratio of the Mortality rate(per 1,000 live births) in Pakistan in 2008 to that in 2011?
Ensure brevity in your answer.  1.04. What is the ratio of the Mortality rate(per 1,000 live births) of East Asia (all income levels) in 2008 to that in 2012?
Provide a short and direct response. 1.26. What is the ratio of the Mortality rate(per 1,000 live births) in Euro area in 2008 to that in 2012?
Ensure brevity in your answer.  1.07. What is the ratio of the Mortality rate(per 1,000 live births) of Nigeria in 2008 to that in 2012?
Your response must be concise. 1.09. What is the ratio of the Mortality rate(per 1,000 live births) of Pakistan in 2008 to that in 2012?
Your response must be concise. 1.06. What is the ratio of the Mortality rate(per 1,000 live births) in East Asia (all income levels) in 2008 to that in 2013?
Give a very brief answer. 1.33. What is the ratio of the Mortality rate(per 1,000 live births) in Euro area in 2008 to that in 2013?
Give a very brief answer. 1.09. What is the ratio of the Mortality rate(per 1,000 live births) of Nigeria in 2008 to that in 2013?
Your answer should be very brief. 1.11. What is the ratio of the Mortality rate(per 1,000 live births) of Pakistan in 2008 to that in 2013?
Ensure brevity in your answer.  1.08. What is the ratio of the Mortality rate(per 1,000 live births) in East Asia (all income levels) in 2008 to that in 2014?
Your response must be concise. 1.4. What is the ratio of the Mortality rate(per 1,000 live births) in Euro area in 2008 to that in 2014?
Keep it short and to the point. 1.12. What is the ratio of the Mortality rate(per 1,000 live births) in Nigeria in 2008 to that in 2014?
Keep it short and to the point. 1.14. What is the ratio of the Mortality rate(per 1,000 live births) in Pakistan in 2008 to that in 2014?
Offer a very short reply. 1.1. What is the ratio of the Mortality rate(per 1,000 live births) in East Asia (all income levels) in 2008 to that in 2015?
Ensure brevity in your answer.  1.46. What is the ratio of the Mortality rate(per 1,000 live births) of Euro area in 2008 to that in 2015?
Offer a terse response. 1.15. What is the ratio of the Mortality rate(per 1,000 live births) in Nigeria in 2008 to that in 2015?
Provide a succinct answer. 1.16. What is the ratio of the Mortality rate(per 1,000 live births) of Pakistan in 2008 to that in 2015?
Your answer should be compact. 1.13. What is the ratio of the Mortality rate(per 1,000 live births) of East Asia (all income levels) in 2009 to that in 2010?
Your response must be concise. 1.06. What is the ratio of the Mortality rate(per 1,000 live births) of Euro area in 2009 to that in 2010?
Give a very brief answer. 1.03. What is the ratio of the Mortality rate(per 1,000 live births) in Nigeria in 2009 to that in 2010?
Your answer should be compact. 1.02. What is the ratio of the Mortality rate(per 1,000 live births) of Pakistan in 2009 to that in 2010?
Make the answer very short. 1.01. What is the ratio of the Mortality rate(per 1,000 live births) of East Asia (all income levels) in 2009 to that in 2011?
Offer a very short reply. 1.13. What is the ratio of the Mortality rate(per 1,000 live births) in Euro area in 2009 to that in 2011?
Give a very brief answer. 1.05. What is the ratio of the Mortality rate(per 1,000 live births) in Nigeria in 2009 to that in 2011?
Keep it short and to the point. 1.04. What is the ratio of the Mortality rate(per 1,000 live births) in Pakistan in 2009 to that in 2011?
Offer a very short reply. 1.03. What is the ratio of the Mortality rate(per 1,000 live births) of East Asia (all income levels) in 2009 to that in 2012?
Provide a succinct answer. 1.19. What is the ratio of the Mortality rate(per 1,000 live births) of Euro area in 2009 to that in 2012?
Make the answer very short. 1.06. What is the ratio of the Mortality rate(per 1,000 live births) of Nigeria in 2009 to that in 2012?
Your answer should be compact. 1.07. What is the ratio of the Mortality rate(per 1,000 live births) of Pakistan in 2009 to that in 2012?
Your answer should be compact. 1.05. What is the ratio of the Mortality rate(per 1,000 live births) in East Asia (all income levels) in 2009 to that in 2013?
Keep it short and to the point. 1.25. What is the ratio of the Mortality rate(per 1,000 live births) of Euro area in 2009 to that in 2013?
Your response must be concise. 1.09. What is the ratio of the Mortality rate(per 1,000 live births) of Nigeria in 2009 to that in 2013?
Your response must be concise. 1.09. What is the ratio of the Mortality rate(per 1,000 live births) in Pakistan in 2009 to that in 2013?
Provide a succinct answer. 1.07. What is the ratio of the Mortality rate(per 1,000 live births) of East Asia (all income levels) in 2009 to that in 2014?
Offer a terse response. 1.31. What is the ratio of the Mortality rate(per 1,000 live births) of Euro area in 2009 to that in 2014?
Make the answer very short. 1.11. What is the ratio of the Mortality rate(per 1,000 live births) in Nigeria in 2009 to that in 2014?
Provide a short and direct response. 1.11. What is the ratio of the Mortality rate(per 1,000 live births) of Pakistan in 2009 to that in 2014?
Your answer should be very brief. 1.09. What is the ratio of the Mortality rate(per 1,000 live births) in East Asia (all income levels) in 2009 to that in 2015?
Offer a very short reply. 1.37. What is the ratio of the Mortality rate(per 1,000 live births) of Euro area in 2009 to that in 2015?
Your answer should be very brief. 1.14. What is the ratio of the Mortality rate(per 1,000 live births) in Nigeria in 2009 to that in 2015?
Your answer should be compact. 1.14. What is the ratio of the Mortality rate(per 1,000 live births) of Pakistan in 2009 to that in 2015?
Provide a short and direct response. 1.11. What is the ratio of the Mortality rate(per 1,000 live births) of East Asia (all income levels) in 2010 to that in 2011?
Offer a terse response. 1.06. What is the ratio of the Mortality rate(per 1,000 live births) in Euro area in 2010 to that in 2011?
Your answer should be very brief. 1.02. What is the ratio of the Mortality rate(per 1,000 live births) of Nigeria in 2010 to that in 2011?
Provide a succinct answer. 1.02. What is the ratio of the Mortality rate(per 1,000 live births) of Pakistan in 2010 to that in 2011?
Provide a succinct answer. 1.02. What is the ratio of the Mortality rate(per 1,000 live births) in East Asia (all income levels) in 2010 to that in 2012?
Offer a terse response. 1.12. What is the ratio of the Mortality rate(per 1,000 live births) in Euro area in 2010 to that in 2012?
Keep it short and to the point. 1.03. What is the ratio of the Mortality rate(per 1,000 live births) in Nigeria in 2010 to that in 2012?
Keep it short and to the point. 1.05. What is the ratio of the Mortality rate(per 1,000 live births) in Pakistan in 2010 to that in 2012?
Offer a terse response. 1.03. What is the ratio of the Mortality rate(per 1,000 live births) of East Asia (all income levels) in 2010 to that in 2013?
Provide a succinct answer. 1.18. What is the ratio of the Mortality rate(per 1,000 live births) in Euro area in 2010 to that in 2013?
Your answer should be compact. 1.05. What is the ratio of the Mortality rate(per 1,000 live births) in Nigeria in 2010 to that in 2013?
Provide a short and direct response. 1.07. What is the ratio of the Mortality rate(per 1,000 live births) in Pakistan in 2010 to that in 2013?
Give a very brief answer. 1.05. What is the ratio of the Mortality rate(per 1,000 live births) in East Asia (all income levels) in 2010 to that in 2014?
Give a very brief answer. 1.23. What is the ratio of the Mortality rate(per 1,000 live births) in Euro area in 2010 to that in 2014?
Offer a very short reply. 1.08. What is the ratio of the Mortality rate(per 1,000 live births) of Nigeria in 2010 to that in 2014?
Provide a short and direct response. 1.09. What is the ratio of the Mortality rate(per 1,000 live births) of Pakistan in 2010 to that in 2014?
Ensure brevity in your answer.  1.07. What is the ratio of the Mortality rate(per 1,000 live births) in East Asia (all income levels) in 2010 to that in 2015?
Give a very brief answer. 1.29. What is the ratio of the Mortality rate(per 1,000 live births) in Euro area in 2010 to that in 2015?
Your answer should be compact. 1.1. What is the ratio of the Mortality rate(per 1,000 live births) in Nigeria in 2010 to that in 2015?
Keep it short and to the point. 1.11. What is the ratio of the Mortality rate(per 1,000 live births) in Pakistan in 2010 to that in 2015?
Make the answer very short. 1.1. What is the ratio of the Mortality rate(per 1,000 live births) of East Asia (all income levels) in 2011 to that in 2012?
Provide a succinct answer. 1.05. What is the ratio of the Mortality rate(per 1,000 live births) of Euro area in 2011 to that in 2012?
Ensure brevity in your answer.  1.01. What is the ratio of the Mortality rate(per 1,000 live births) in Nigeria in 2011 to that in 2012?
Provide a short and direct response. 1.02. What is the ratio of the Mortality rate(per 1,000 live births) of Pakistan in 2011 to that in 2012?
Ensure brevity in your answer.  1.02. What is the ratio of the Mortality rate(per 1,000 live births) in East Asia (all income levels) in 2011 to that in 2013?
Your response must be concise. 1.11. What is the ratio of the Mortality rate(per 1,000 live births) of Euro area in 2011 to that in 2013?
Make the answer very short. 1.04. What is the ratio of the Mortality rate(per 1,000 live births) in Nigeria in 2011 to that in 2013?
Offer a very short reply. 1.04. What is the ratio of the Mortality rate(per 1,000 live births) of Pakistan in 2011 to that in 2013?
Offer a very short reply. 1.04. What is the ratio of the Mortality rate(per 1,000 live births) in East Asia (all income levels) in 2011 to that in 2014?
Give a very brief answer. 1.16. What is the ratio of the Mortality rate(per 1,000 live births) of Euro area in 2011 to that in 2014?
Keep it short and to the point. 1.06. What is the ratio of the Mortality rate(per 1,000 live births) in Nigeria in 2011 to that in 2014?
Make the answer very short. 1.07. What is the ratio of the Mortality rate(per 1,000 live births) in Pakistan in 2011 to that in 2014?
Provide a succinct answer. 1.06. What is the ratio of the Mortality rate(per 1,000 live births) of East Asia (all income levels) in 2011 to that in 2015?
Offer a terse response. 1.22. What is the ratio of the Mortality rate(per 1,000 live births) in Euro area in 2011 to that in 2015?
Provide a succinct answer. 1.09. What is the ratio of the Mortality rate(per 1,000 live births) in Nigeria in 2011 to that in 2015?
Make the answer very short. 1.09. What is the ratio of the Mortality rate(per 1,000 live births) of Pakistan in 2011 to that in 2015?
Give a very brief answer. 1.08. What is the ratio of the Mortality rate(per 1,000 live births) of East Asia (all income levels) in 2012 to that in 2013?
Your answer should be compact. 1.06. What is the ratio of the Mortality rate(per 1,000 live births) in Nigeria in 2012 to that in 2013?
Provide a short and direct response. 1.02. What is the ratio of the Mortality rate(per 1,000 live births) of Pakistan in 2012 to that in 2013?
Provide a succinct answer. 1.02. What is the ratio of the Mortality rate(per 1,000 live births) in East Asia (all income levels) in 2012 to that in 2014?
Provide a succinct answer. 1.11. What is the ratio of the Mortality rate(per 1,000 live births) of Euro area in 2012 to that in 2014?
Offer a terse response. 1.04. What is the ratio of the Mortality rate(per 1,000 live births) of Nigeria in 2012 to that in 2014?
Keep it short and to the point. 1.04. What is the ratio of the Mortality rate(per 1,000 live births) in Pakistan in 2012 to that in 2014?
Offer a terse response. 1.04. What is the ratio of the Mortality rate(per 1,000 live births) of East Asia (all income levels) in 2012 to that in 2015?
Ensure brevity in your answer.  1.16. What is the ratio of the Mortality rate(per 1,000 live births) in Euro area in 2012 to that in 2015?
Ensure brevity in your answer.  1.07. What is the ratio of the Mortality rate(per 1,000 live births) of Nigeria in 2012 to that in 2015?
Provide a short and direct response. 1.06. What is the ratio of the Mortality rate(per 1,000 live births) of Pakistan in 2012 to that in 2015?
Ensure brevity in your answer.  1.06. What is the ratio of the Mortality rate(per 1,000 live births) of East Asia (all income levels) in 2013 to that in 2014?
Make the answer very short. 1.05. What is the ratio of the Mortality rate(per 1,000 live births) of Nigeria in 2013 to that in 2014?
Make the answer very short. 1.02. What is the ratio of the Mortality rate(per 1,000 live births) in Pakistan in 2013 to that in 2014?
Your answer should be compact. 1.02. What is the ratio of the Mortality rate(per 1,000 live births) in East Asia (all income levels) in 2013 to that in 2015?
Make the answer very short. 1.09. What is the ratio of the Mortality rate(per 1,000 live births) of Euro area in 2013 to that in 2015?
Keep it short and to the point. 1.05. What is the ratio of the Mortality rate(per 1,000 live births) in Nigeria in 2013 to that in 2015?
Your answer should be compact. 1.04. What is the ratio of the Mortality rate(per 1,000 live births) of Pakistan in 2013 to that in 2015?
Keep it short and to the point. 1.04. What is the ratio of the Mortality rate(per 1,000 live births) in East Asia (all income levels) in 2014 to that in 2015?
Give a very brief answer. 1.05. What is the ratio of the Mortality rate(per 1,000 live births) of Euro area in 2014 to that in 2015?
Make the answer very short. 1.03. What is the ratio of the Mortality rate(per 1,000 live births) in Nigeria in 2014 to that in 2015?
Make the answer very short. 1.02. What is the ratio of the Mortality rate(per 1,000 live births) in Pakistan in 2014 to that in 2015?
Ensure brevity in your answer.  1.02. What is the difference between the highest and the second highest Mortality rate(per 1,000 live births) in East Asia (all income levels)?
Your answer should be very brief. 0.74. What is the difference between the highest and the second highest Mortality rate(per 1,000 live births) in Euro area?
Offer a terse response. 0.02. What is the difference between the highest and the second highest Mortality rate(per 1,000 live births) of Nigeria?
Your answer should be compact. 0.8. What is the difference between the highest and the second highest Mortality rate(per 1,000 live births) in Pakistan?
Provide a short and direct response. 0.6. What is the difference between the highest and the lowest Mortality rate(per 1,000 live births) of East Asia (all income levels)?
Make the answer very short. 3.91. What is the difference between the highest and the lowest Mortality rate(per 1,000 live births) of Euro area?
Offer a very short reply. 0.33. What is the difference between the highest and the lowest Mortality rate(per 1,000 live births) of Nigeria?
Offer a very short reply. 5.5. 